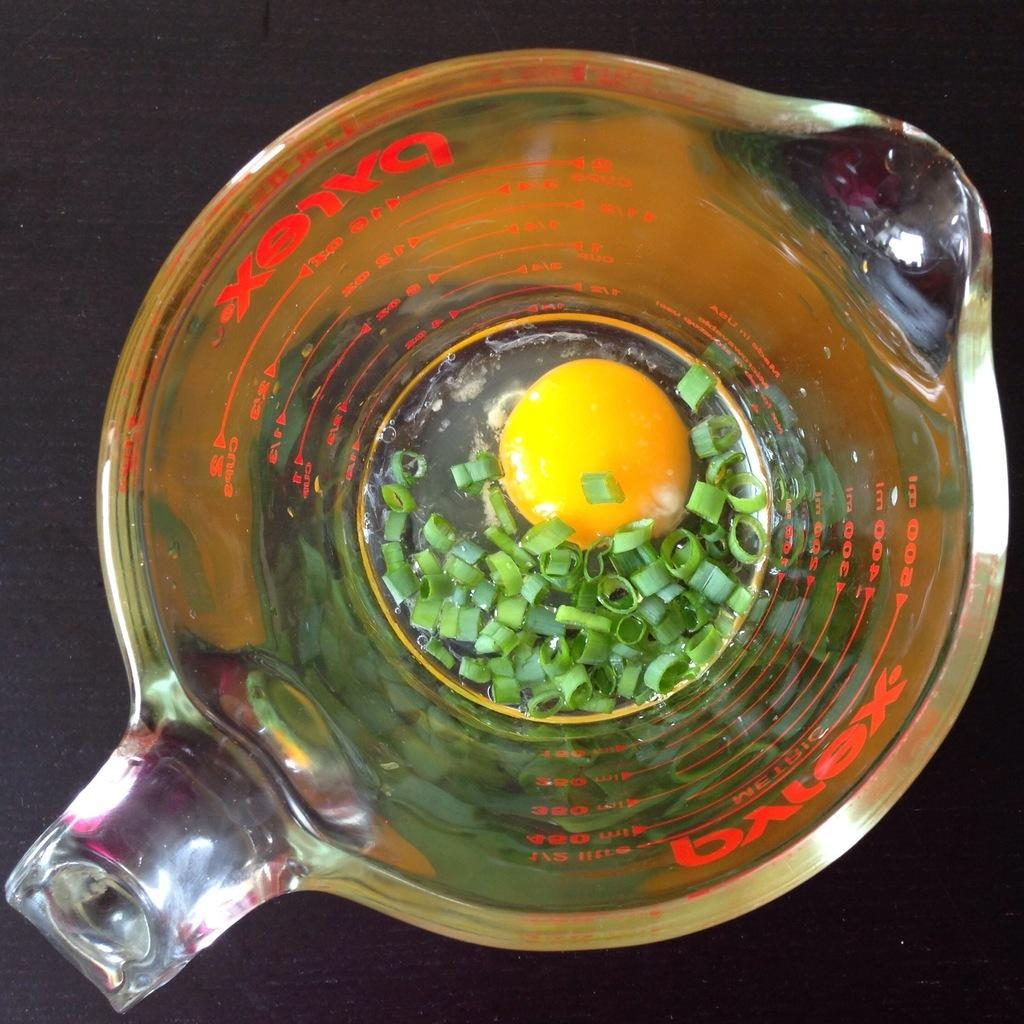Provide a one-sentence caption for the provided image. A glass Pyrex measuring cup which contains chopped green onions and an egg yolk. 